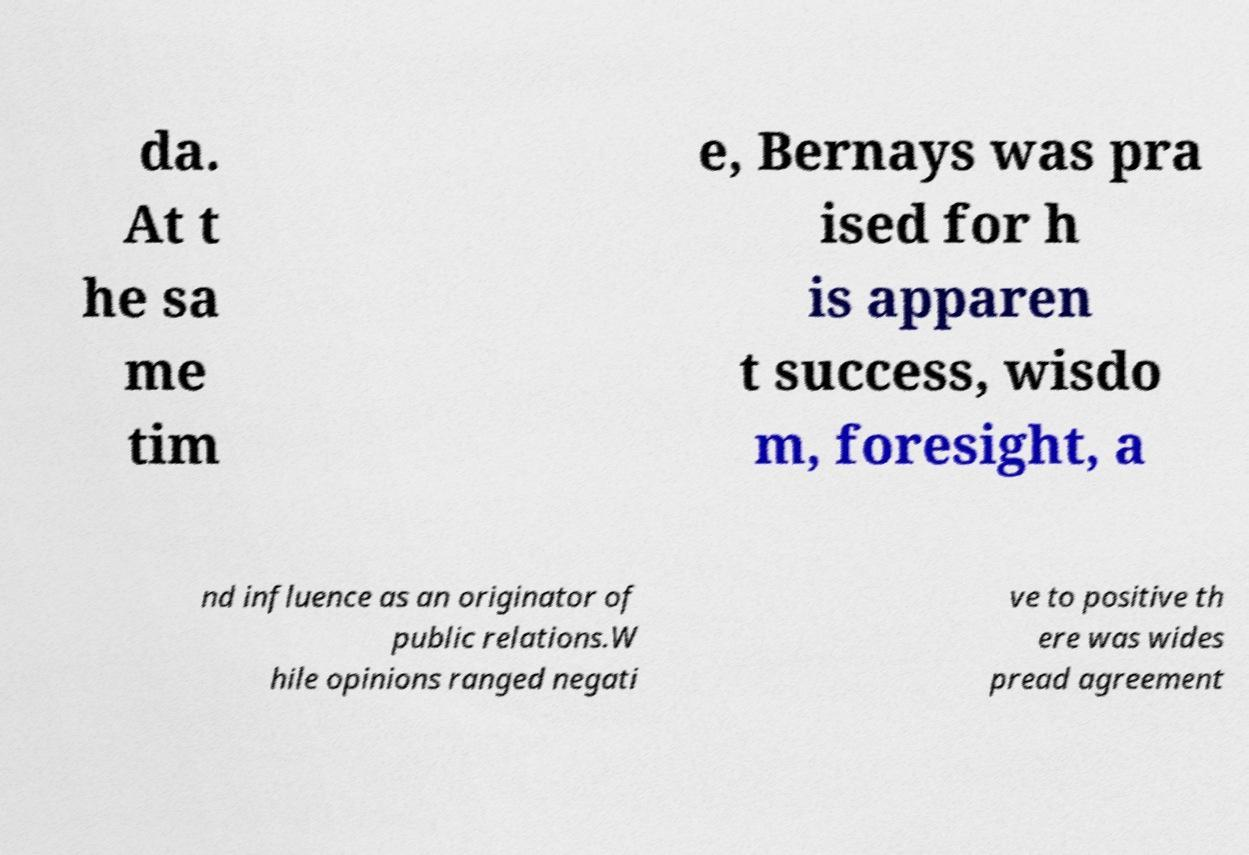Can you accurately transcribe the text from the provided image for me? da. At t he sa me tim e, Bernays was pra ised for h is apparen t success, wisdo m, foresight, a nd influence as an originator of public relations.W hile opinions ranged negati ve to positive th ere was wides pread agreement 